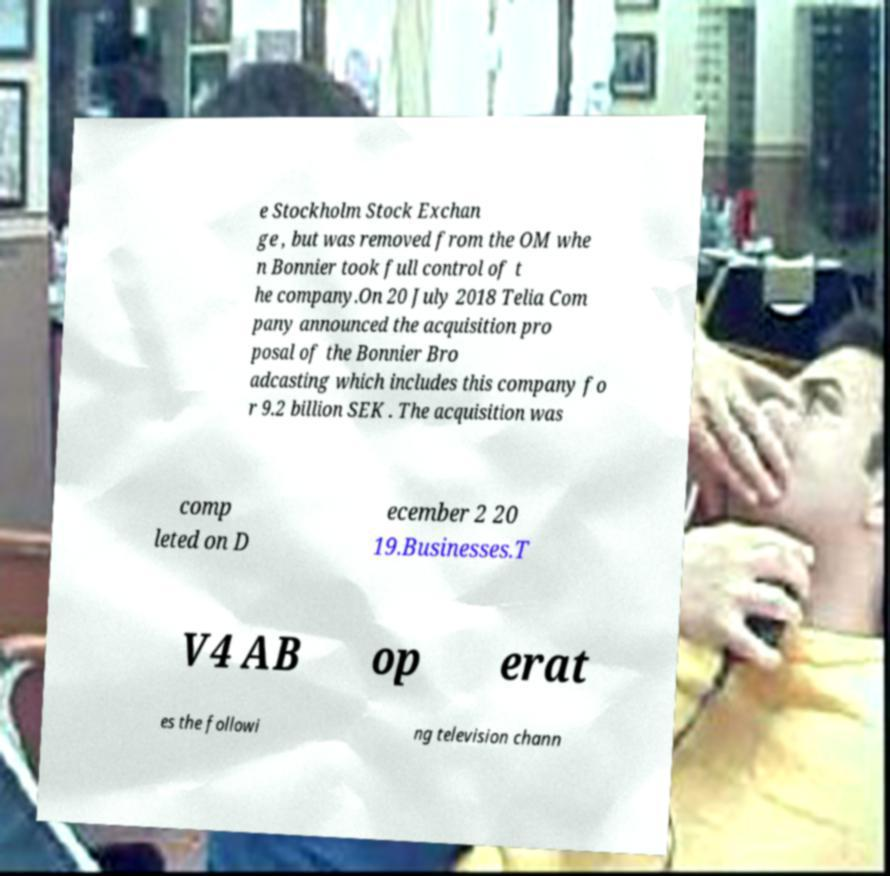Please identify and transcribe the text found in this image. e Stockholm Stock Exchan ge , but was removed from the OM whe n Bonnier took full control of t he company.On 20 July 2018 Telia Com pany announced the acquisition pro posal of the Bonnier Bro adcasting which includes this company fo r 9.2 billion SEK . The acquisition was comp leted on D ecember 2 20 19.Businesses.T V4 AB op erat es the followi ng television chann 